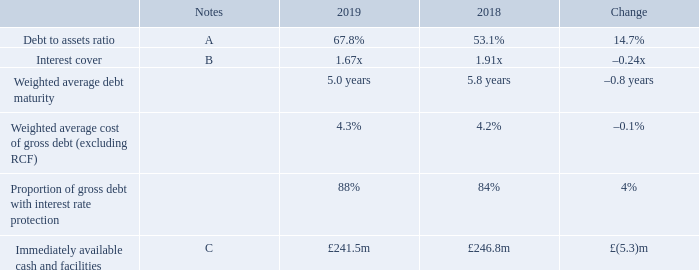Subsequent to the year end, we have received the final ratifications required for full planning to become effective and therefore we expect the positive impact on retained earnings to reverse once these arrangements are formally concluded. In this event EPRA NAV per share would have been 143 pence.
Debt measures
A Debt to asset ratio
Our debt to assets ratio increased to 67.8 per cent in 2019 due to the property revaluation deficit in the year. This reduces to 65.3 per cent when adjusted for expected disposal proceeds from intu Puerto Venecia and intu Asturias.
B Interest cover
Interest cover of 1.67x remains above our target minimum level of 1.60x although it has reduced in 2019 as a result of the reduction in net rental income.
C Immediately available cash and facilities
Immediately available cash and facilities has reduced in the year by £5.3 million to £241.5 million at 31 December 2019. This excludes the rents collected at the end of December 2019 which relate to the first quarter of 2020 and remain in the debt structures until interest payments are made. At 10 March 2020, immediately available cash and facilities is £200.3 million, which will be augmented by the intu Puerto Venecia sales proceeds expected to be received in early April.
What is debt to assets ratio in 2019?
Answer scale should be: percent. 67.8. What is the weighted average debt maturity in 2019? 5.0 years. What is the weighted average cost of gross debt (excluding RCF) in 2019?
Answer scale should be: percent. 4.3. What is the percentage change in the immediately available cash and facilities from 2018 to 2019?
Answer scale should be: percent. (5.3)/246.8
Answer: -2.15. What is the change in the proportion of gross debt with interest rate protection from 2018 to 2019?
Answer scale should be: percent. 88-84
Answer: 4. What is the change in the debt to assets ration from 2018 to 2019 when it is adjusted for expected disposal proceeds from intu Puerto Venecia and intu Asturias?
Answer scale should be: percent. 65.3-53.1
Answer: 12.2. 